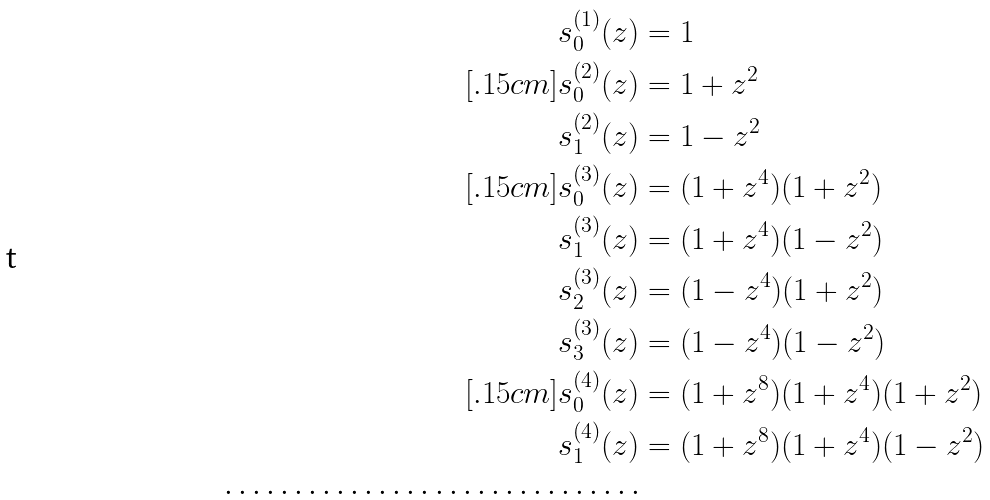<formula> <loc_0><loc_0><loc_500><loc_500>s _ { 0 } ^ { ( 1 ) } ( z ) & = 1 \\ [ . 1 5 c m ] s _ { 0 } ^ { ( 2 ) } ( z ) & = 1 + z ^ { 2 } \\ s _ { 1 } ^ { ( 2 ) } ( z ) & = 1 - z ^ { 2 } \\ [ . 1 5 c m ] s _ { 0 } ^ { ( 3 ) } ( z ) & = ( 1 + z ^ { 4 } ) ( 1 + z ^ { 2 } ) \\ s _ { 1 } ^ { ( 3 ) } ( z ) & = ( 1 + z ^ { 4 } ) ( 1 - z ^ { 2 } ) \\ s _ { 2 } ^ { ( 3 ) } ( z ) & = ( 1 - z ^ { 4 } ) ( 1 + z ^ { 2 } ) \\ s _ { 3 } ^ { ( 3 ) } ( z ) & = ( 1 - z ^ { 4 } ) ( 1 - z ^ { 2 } ) \\ [ . 1 5 c m ] s _ { 0 } ^ { ( 4 ) } ( z ) & = ( 1 + z ^ { 8 } ) ( 1 + z ^ { 4 } ) ( 1 + z ^ { 2 } ) \\ s _ { 1 } ^ { ( 4 ) } ( z ) & = ( 1 + z ^ { 8 } ) ( 1 + z ^ { 4 } ) ( 1 - z ^ { 2 } ) \\ \cdots \cdots \cdots \cdots \cdots \cdots \cdots \cdots \cdots \cdots</formula> 